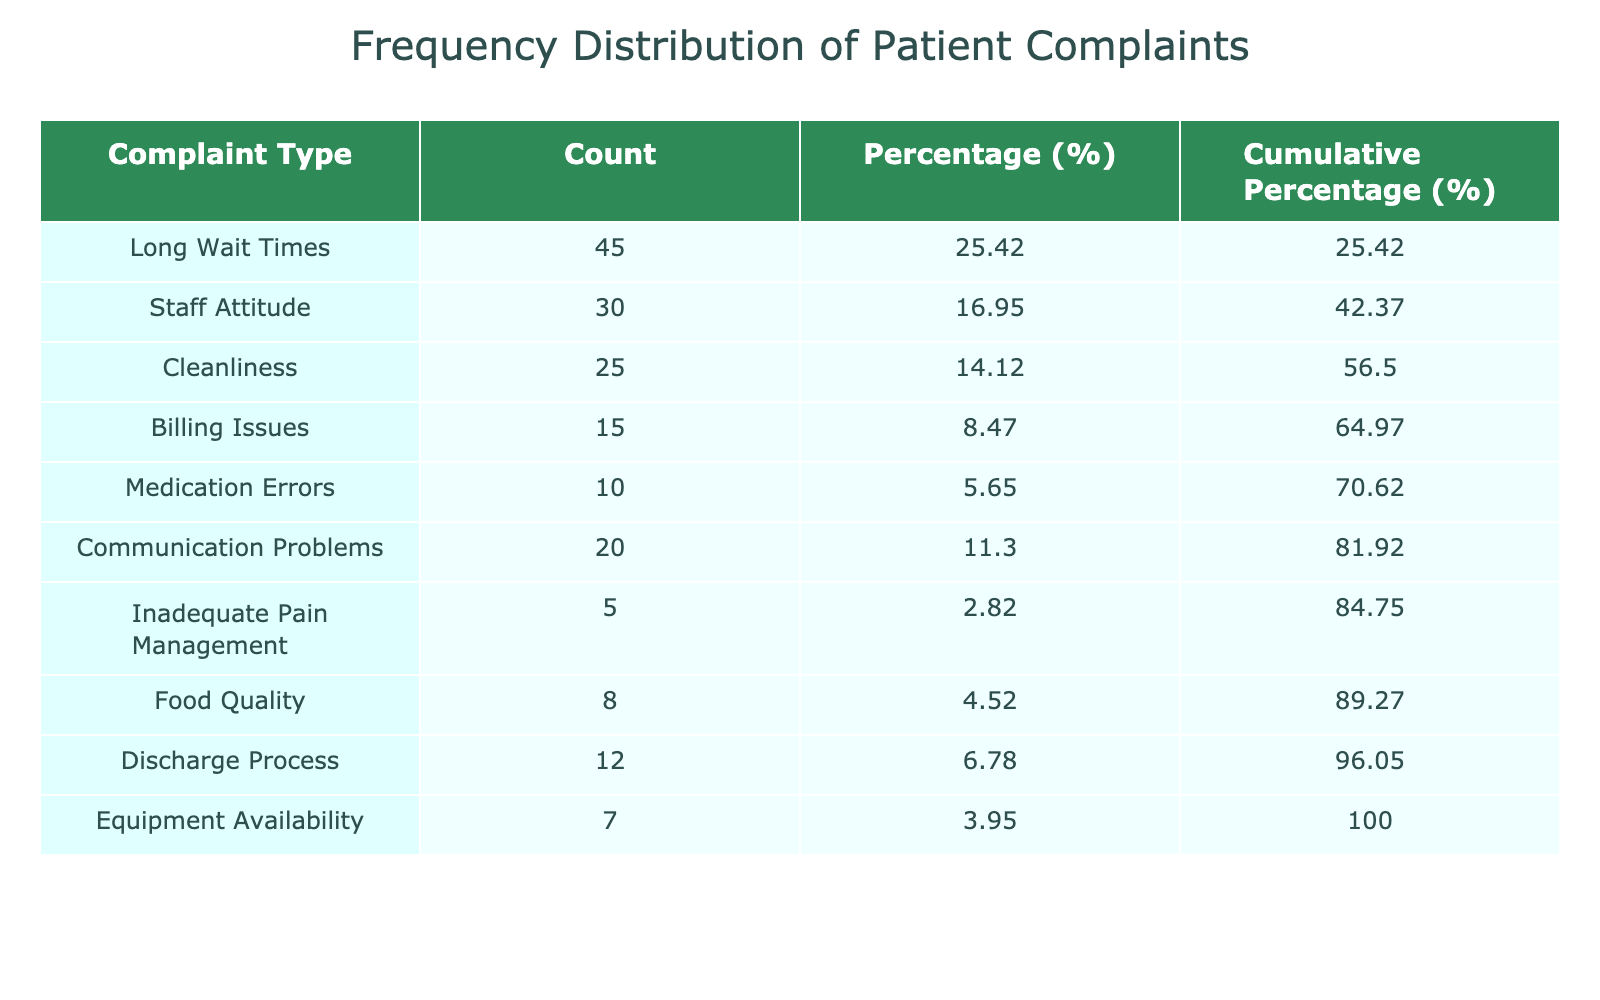What is the count of complaints related to Long Wait Times? The table shows a specific count for each complaint type. For Long Wait Times, the count is listed directly in the corresponding row.
Answer: 45 What percentage of complaints are due to Staff Attitude? The total count of complaints is the sum of all counts, which is 45 + 30 + 25 + 15 + 10 + 20 + 5 + 8 + 12 + 7 =  177. The percentage for Staff Attitude is calculated by dividing the count for Staff Attitude (30) by the total count (177), and then multiplying by 100. The result is (30/177) * 100 ≈ 16.95%.
Answer: 16.95% Is the count of Food Quality complaints greater than the count of Billing Issues complaints? The count of Food Quality complaints is 8, while the count of Billing Issues complaints is 15. Comparing these two counts, 8 is less than 15, making the statement false.
Answer: No What is the cumulative percentage of Medication Errors complaints? To find the cumulative percentage, we look at the cumulative percentages up to and including Medication Errors. The cumulative percentage for Medication Errors can be calculated as: Long Wait Times (25.41%) + Staff Attitude (16.95%) + Cleanliness (14.09%) + Billing Issues (8.48%) + Medication Errors (5.65%) = 70.58%.
Answer: 70.58% How many more complaints were reported for Communication Problems than for Inadequate Pain Management? The count for Communication Problems is 20, while the count for Inadequate Pain Management is 5. Therefore, to find how many more were reported, we subtract: 20 - 5 = 15.
Answer: 15 What is the total count of complaints for the top three categories? The top three categories are Long Wait Times (45), Staff Attitude (30), and Cleanliness (25). To find the total count, we sum these values: 45 + 30 + 25 = 100.
Answer: 100 Are the number of complaints about Equipment Availability and Food Quality combined less than the number of complaints for Long Wait Times? The count for Equipment Availability is 7, and for Food Quality, it is 8. Combining them gives a total of 7 + 8 = 15. Long Wait Times has a count of 45, so we compare: 15 < 45. Thus, the statement is true.
Answer: Yes What is the average count of complaints across all categories? To find the average, we take the total count of complaints (177) and divide it by the number of categories (10). Thus, 177 / 10 = 17.7.
Answer: 17.7 